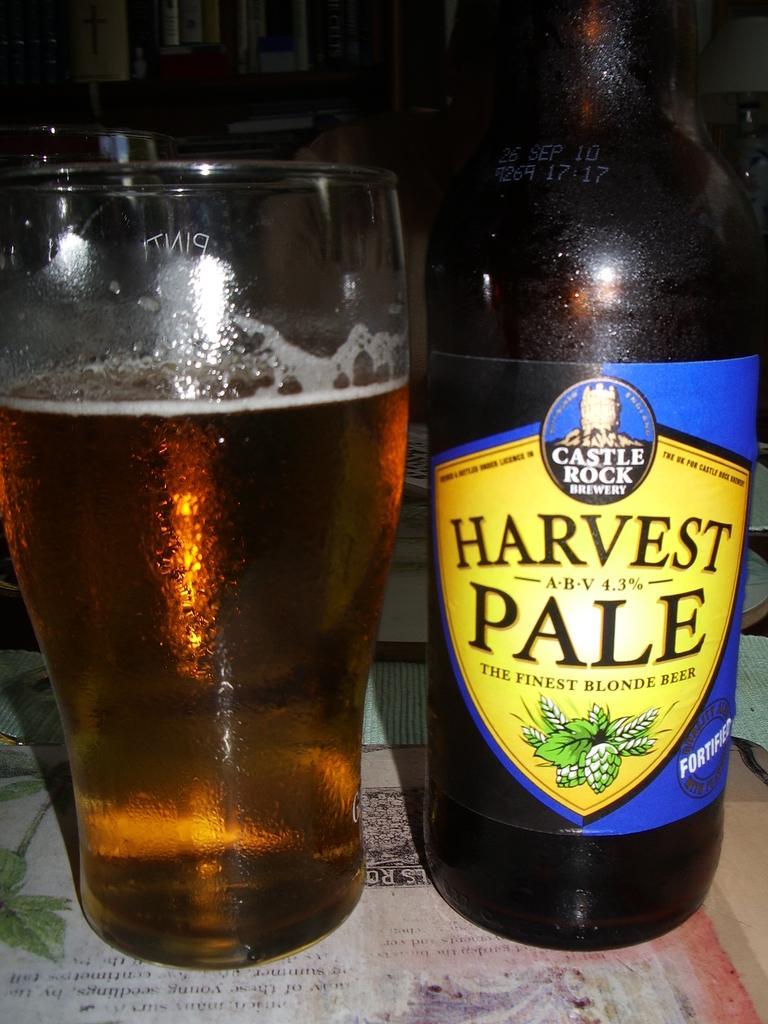Please provide a concise description of this image. In this image there is a beer bottle with a label to it and a glass of beer, on the table, and there is dark background. 